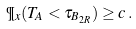<formula> <loc_0><loc_0><loc_500><loc_500>\P _ { x } ( T _ { A } < \tau _ { B _ { 2 R } } ) \geq c \, .</formula> 